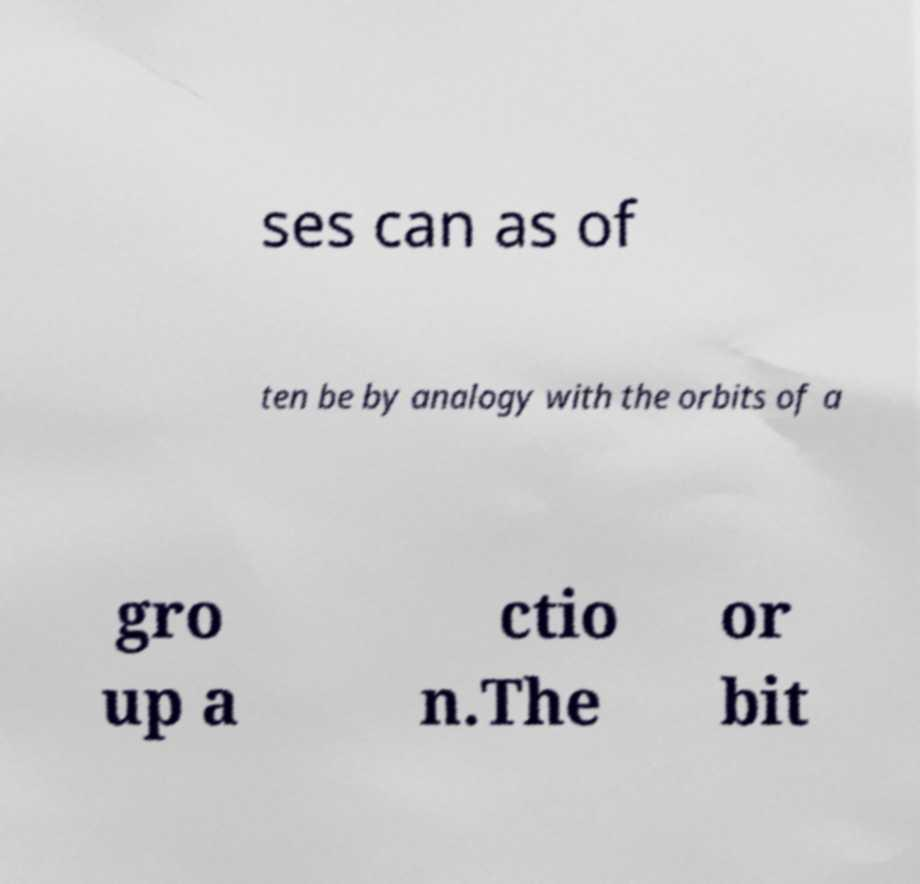Please identify and transcribe the text found in this image. ses can as of ten be by analogy with the orbits of a gro up a ctio n.The or bit 